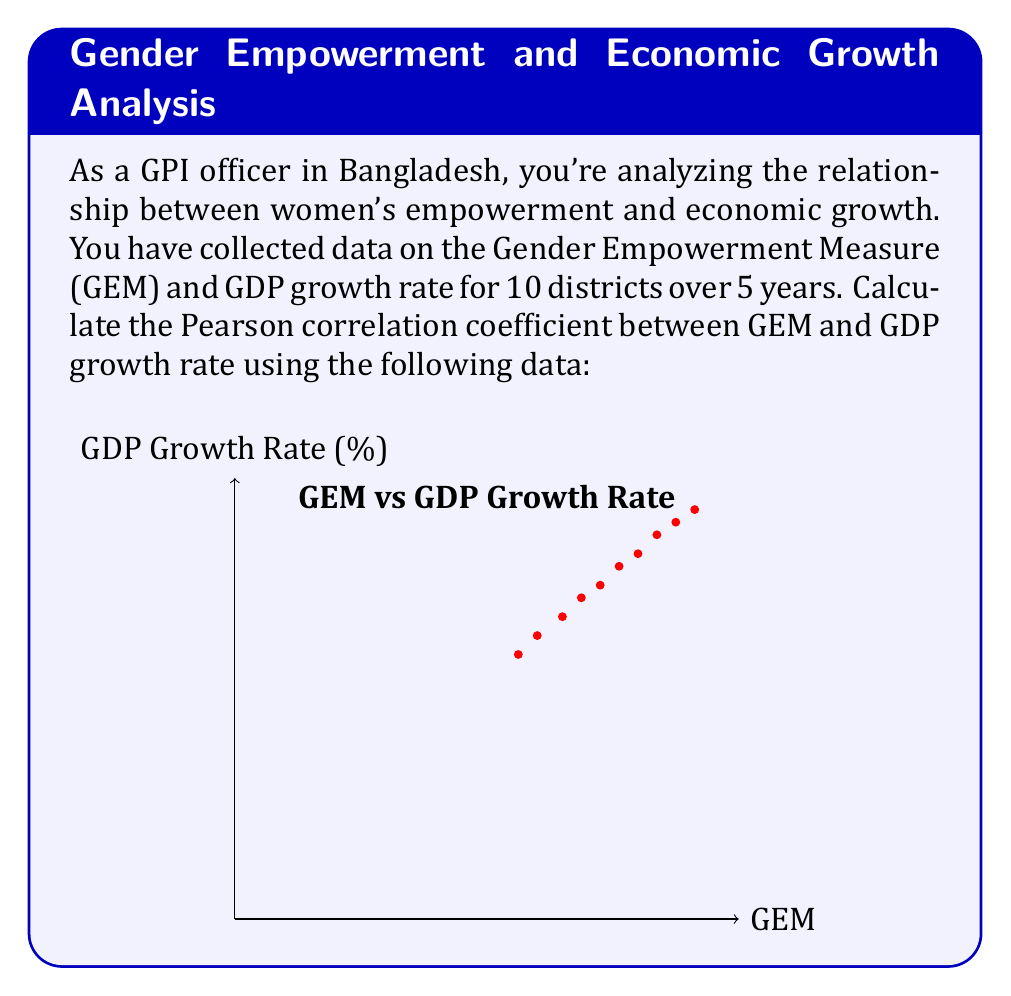Solve this math problem. To calculate the Pearson correlation coefficient (r) between the Gender Empowerment Measure (GEM) and GDP growth rate, we'll use the following formula:

$$ r = \frac{\sum_{i=1}^{n} (x_i - \bar{x})(y_i - \bar{y})}{\sqrt{\sum_{i=1}^{n} (x_i - \bar{x})^2 \sum_{i=1}^{n} (y_i - \bar{y})^2}} $$

Where:
$x_i$ = GEM values
$y_i$ = GDP growth rate values
$\bar{x}$ = Mean of GEM values
$\bar{y}$ = Mean of GDP growth rate values
$n$ = Number of data points (10 in this case)

Step 1: Calculate means
$\bar{x} = \frac{0.45 + 0.48 + 0.52 + 0.55 + 0.58 + 0.61 + 0.64 + 0.67 + 0.70 + 0.73}{10} = 0.593$
$\bar{y} = \frac{4.2 + 4.5 + 4.8 + 5.1 + 5.3 + 5.6 + 5.8 + 6.1 + 6.3 + 6.5}{10} = 5.42$

Step 2: Calculate $(x_i - \bar{x})(y_i - \bar{y})$, $(x_i - \bar{x})^2$, and $(y_i - \bar{y})^2$ for each data point

Step 3: Sum the results
$\sum (x_i - \bar{x})(y_i - \bar{y}) = 0.2765$
$\sum (x_i - \bar{x})^2 = 0.0749$
$\sum (y_i - \bar{y})^2 = 5.076$

Step 4: Apply the formula
$$ r = \frac{0.2765}{\sqrt{0.0749 \times 5.076}} = \frac{0.2765}{0.6164} = 0.9982 $$
Answer: $r = 0.9982$ 